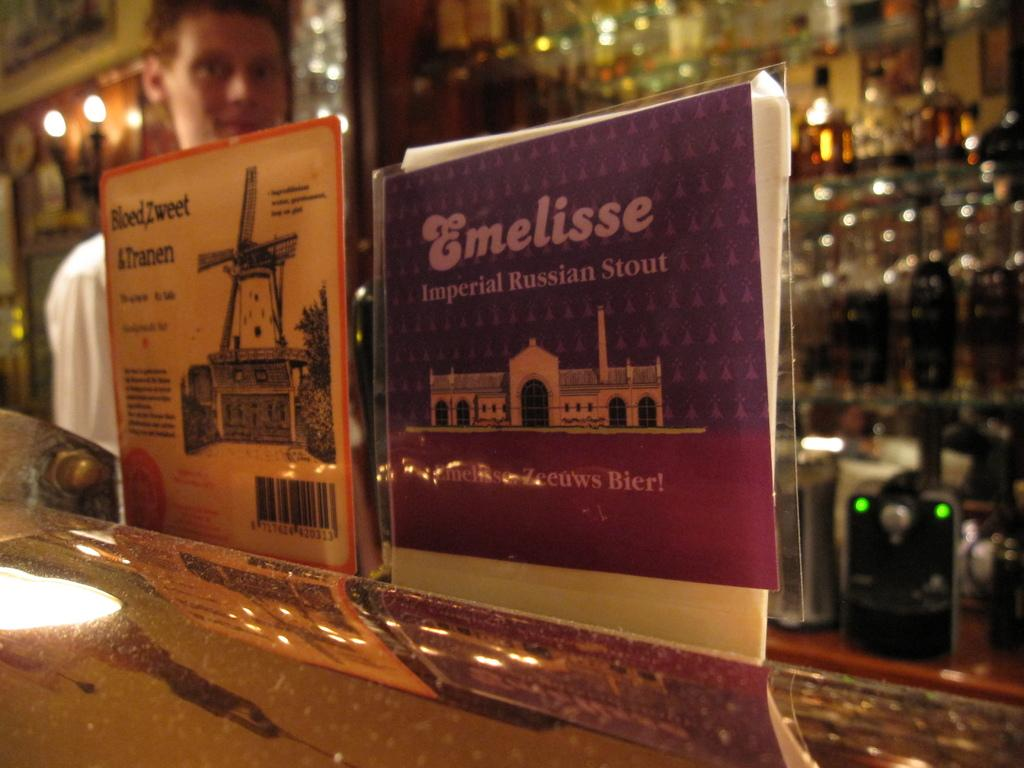Who is present in the image? There is a man in the image. What is the man standing near? There is a table in the image. What are the posts used for in the image? The posts are used to support the structure in the image. What are the lights used for in the image? The lights provide illumination in the image. What is the rack used for in the image? The rack is used for storage in the image. What are the bottles used for in the image? The bottles are used for holding liquid in the image. What is the device used for in the image? The device is used for a specific function in the image, but we cannot determine its purpose without more information. How many cherries are on the table in the image? There are no cherries present in the image. What is the man's reaction to the surprise in the image? There is no surprise or reaction to it in the image. 